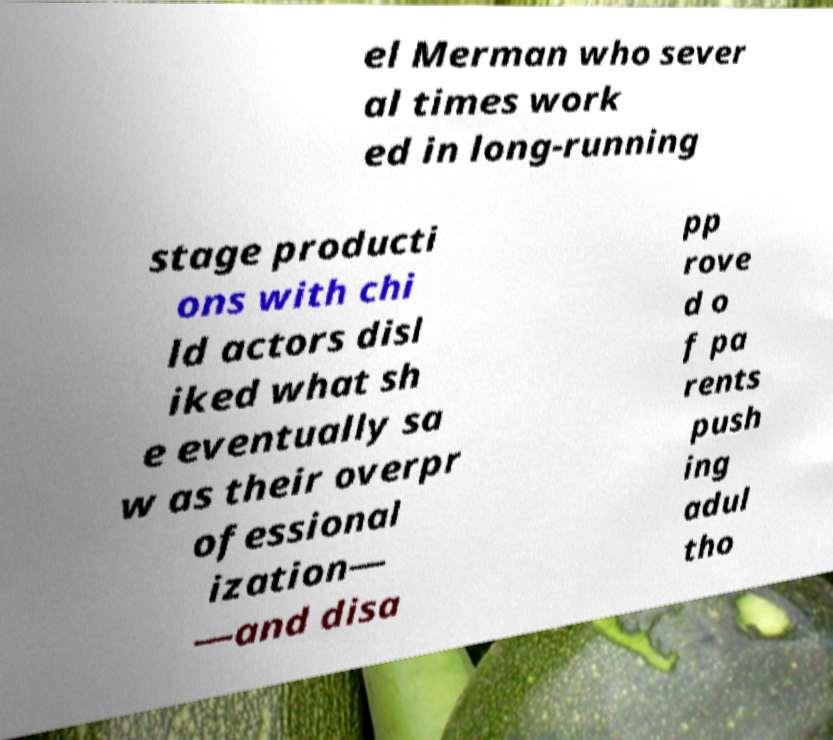There's text embedded in this image that I need extracted. Can you transcribe it verbatim? el Merman who sever al times work ed in long-running stage producti ons with chi ld actors disl iked what sh e eventually sa w as their overpr ofessional ization— —and disa pp rove d o f pa rents push ing adul tho 